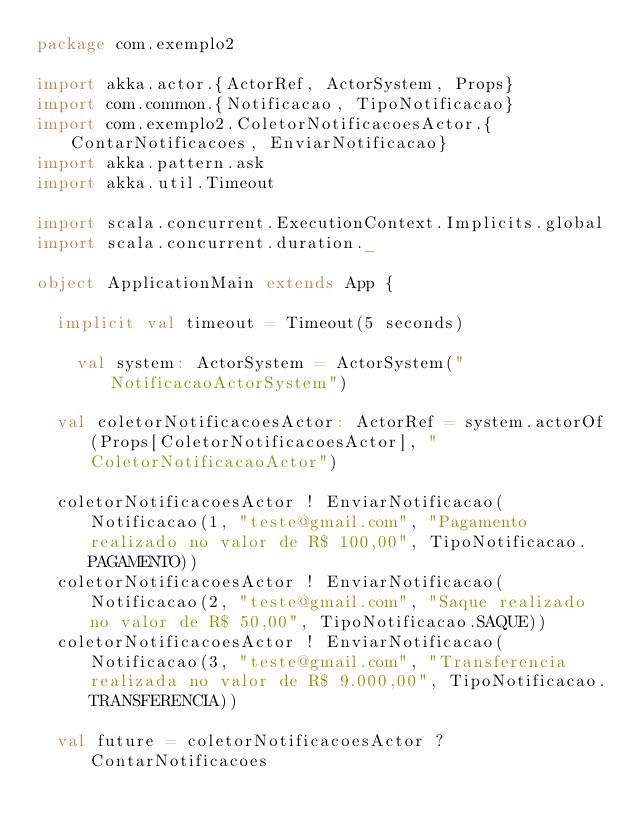<code> <loc_0><loc_0><loc_500><loc_500><_Scala_>package com.exemplo2

import akka.actor.{ActorRef, ActorSystem, Props}
import com.common.{Notificacao, TipoNotificacao}
import com.exemplo2.ColetorNotificacoesActor.{ContarNotificacoes, EnviarNotificacao}
import akka.pattern.ask
import akka.util.Timeout

import scala.concurrent.ExecutionContext.Implicits.global
import scala.concurrent.duration._

object ApplicationMain extends App {

  implicit val timeout = Timeout(5 seconds)

	val system: ActorSystem = ActorSystem("NotificacaoActorSystem")

  val coletorNotificacoesActor: ActorRef = system.actorOf(Props[ColetorNotificacoesActor], "ColetorNotificacaoActor")

  coletorNotificacoesActor ! EnviarNotificacao(Notificacao(1, "teste@gmail.com", "Pagamento realizado no valor de R$ 100,00", TipoNotificacao.PAGAMENTO))
  coletorNotificacoesActor ! EnviarNotificacao(Notificacao(2, "teste@gmail.com", "Saque realizado no valor de R$ 50,00", TipoNotificacao.SAQUE))
  coletorNotificacoesActor ! EnviarNotificacao(Notificacao(3, "teste@gmail.com", "Transferencia realizada no valor de R$ 9.000,00", TipoNotificacao.TRANSFERENCIA))

  val future = coletorNotificacoesActor ? ContarNotificacoes
</code> 